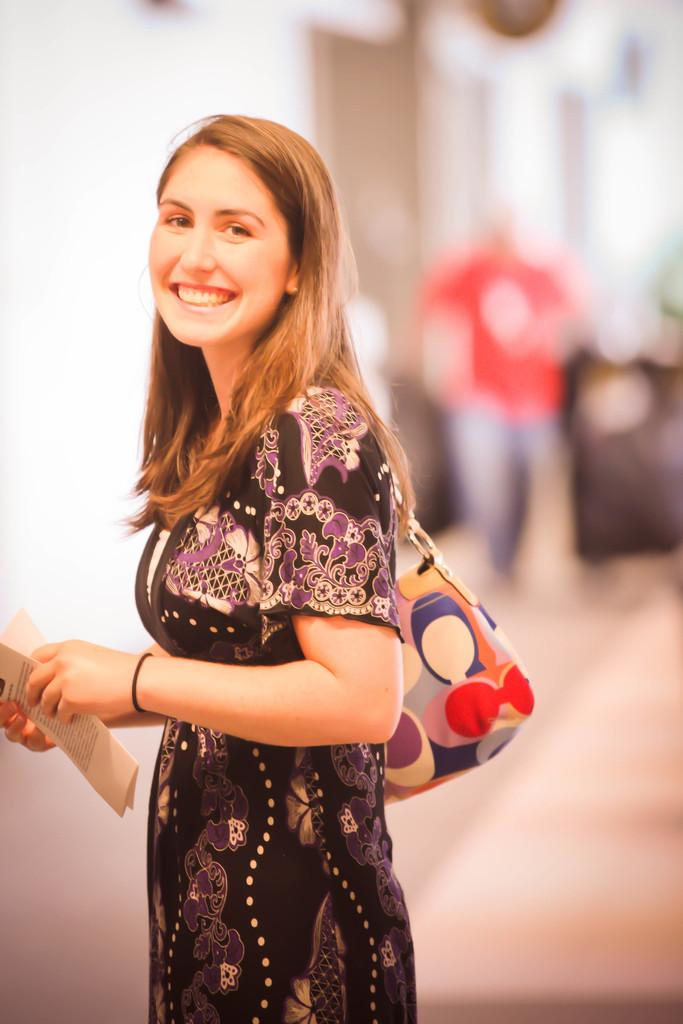Who is the main subject in the image? There is a woman in the image. Where is the woman positioned in the image? The woman is standing in the center of the image. What expression does the woman have? The woman is smiling. What is the woman holding in her hand? The woman is holding papers in her hand. Can you describe the background of the image? The background of the image is blurry. What type of stocking is the woman wearing in the image? There is no mention of stockings or any clothing items in the image, so it cannot be determined what type of stocking the woman might be wearing. 